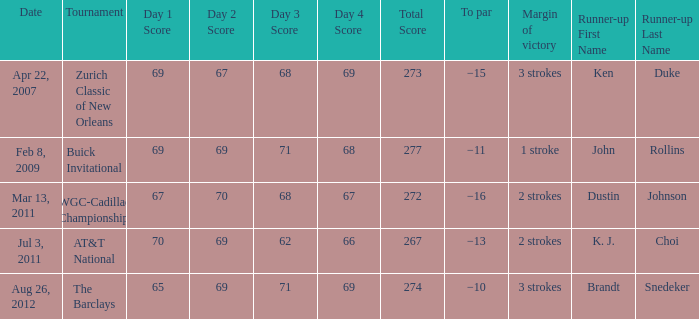Who was the runner-up in the tournament that has a margin of victory of 2 strokes, and a To par of −16? Dustin Johnson. 